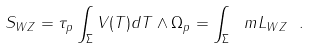<formula> <loc_0><loc_0><loc_500><loc_500>S _ { W Z } = \tau _ { p } \int _ { \Sigma } V ( T ) d T \wedge \Omega _ { p } = \int _ { \Sigma } \ m L _ { W Z } \ .</formula> 